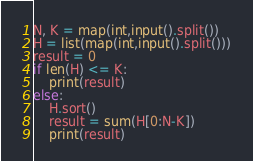<code> <loc_0><loc_0><loc_500><loc_500><_Python_>N, K = map(int,input().split())
H = list(map(int,input().split()))
result = 0
if len(H) <= K:
    print(result)
else:
    H.sort()
    result = sum(H[0:N-K])
    print(result)</code> 